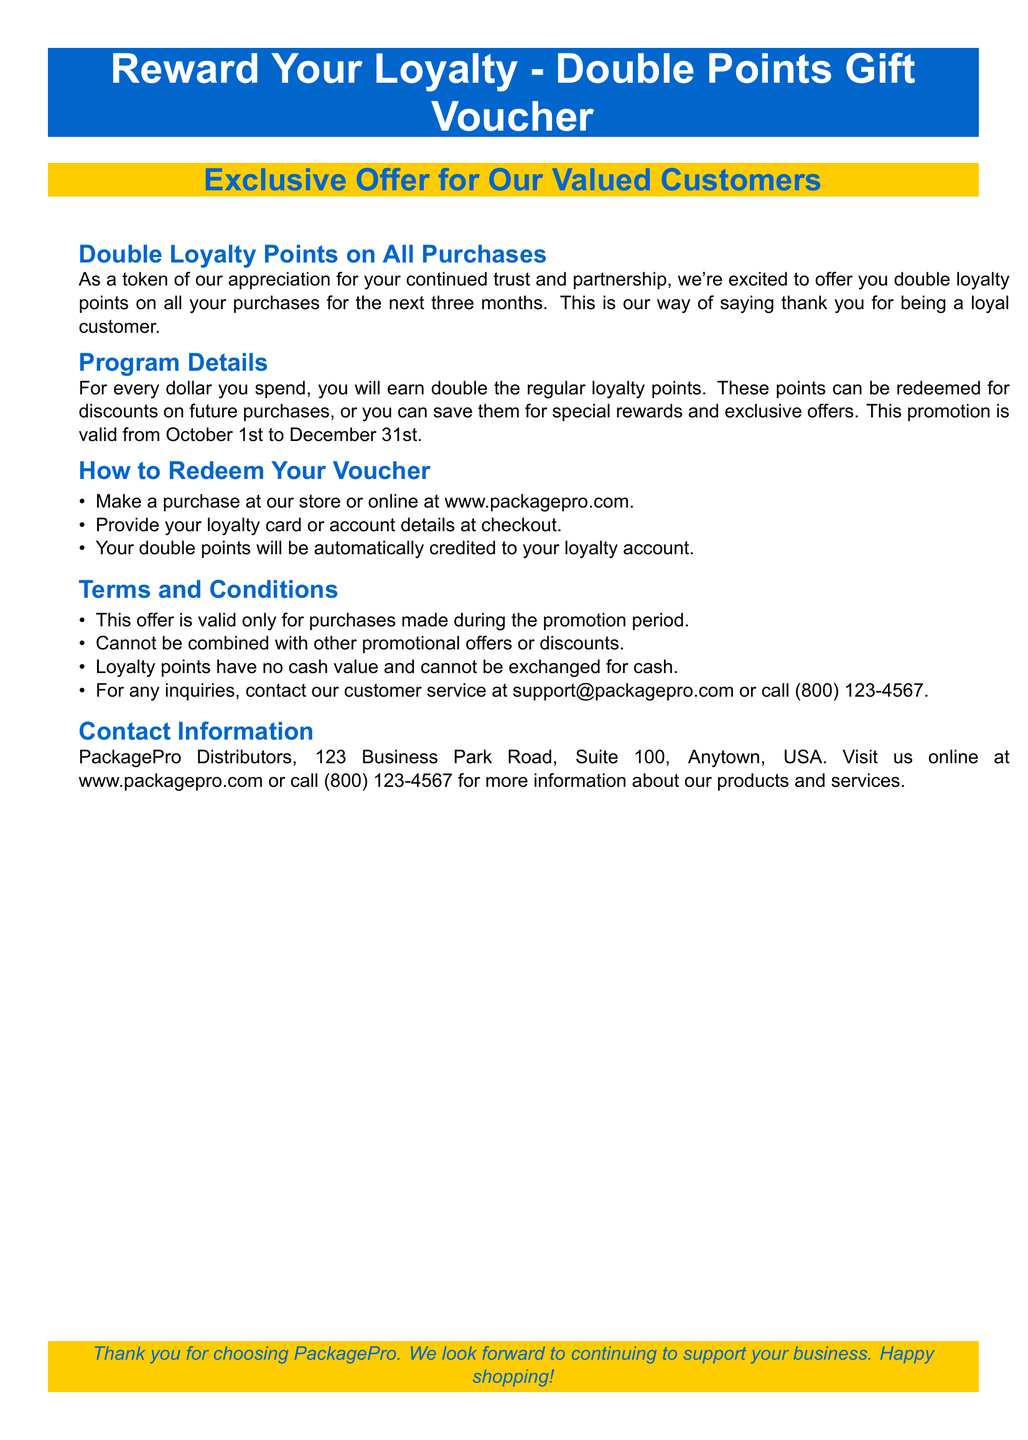what is the offer for regular customers? The offer states that regular customers will receive double loyalty points on all purchases.
Answer: double loyalty points how long is the promotional period? The promotional period lasts from October 1st to December 31st.
Answer: three months where can customers make their purchases to redeem this offer? Customers can make their purchases at the store or online at the specified website.
Answer: www.packagepro.com what should customers show at checkout to earn double points? Customers should provide their loyalty card or account details at checkout.
Answer: loyalty card can the loyalty points be exchanged for cash? The document specifies that loyalty points cannot be exchanged for cash.
Answer: no what is the contact number for customer service inquiries? The contact number for customer service is mentioned in the document for inquiries.
Answer: (800) 123-4567 is this offer valid for all purchases? The offer is only valid for purchases made during the promotion period according to the terms.
Answer: during the promotion period what color is used for the main title of the voucher? The main title of the voucher is presented in a white color on a blue background.
Answer: white what department is responsible for inquiries according to the document? The document states that customer service is responsible for handling inquiries.
Answer: customer service 